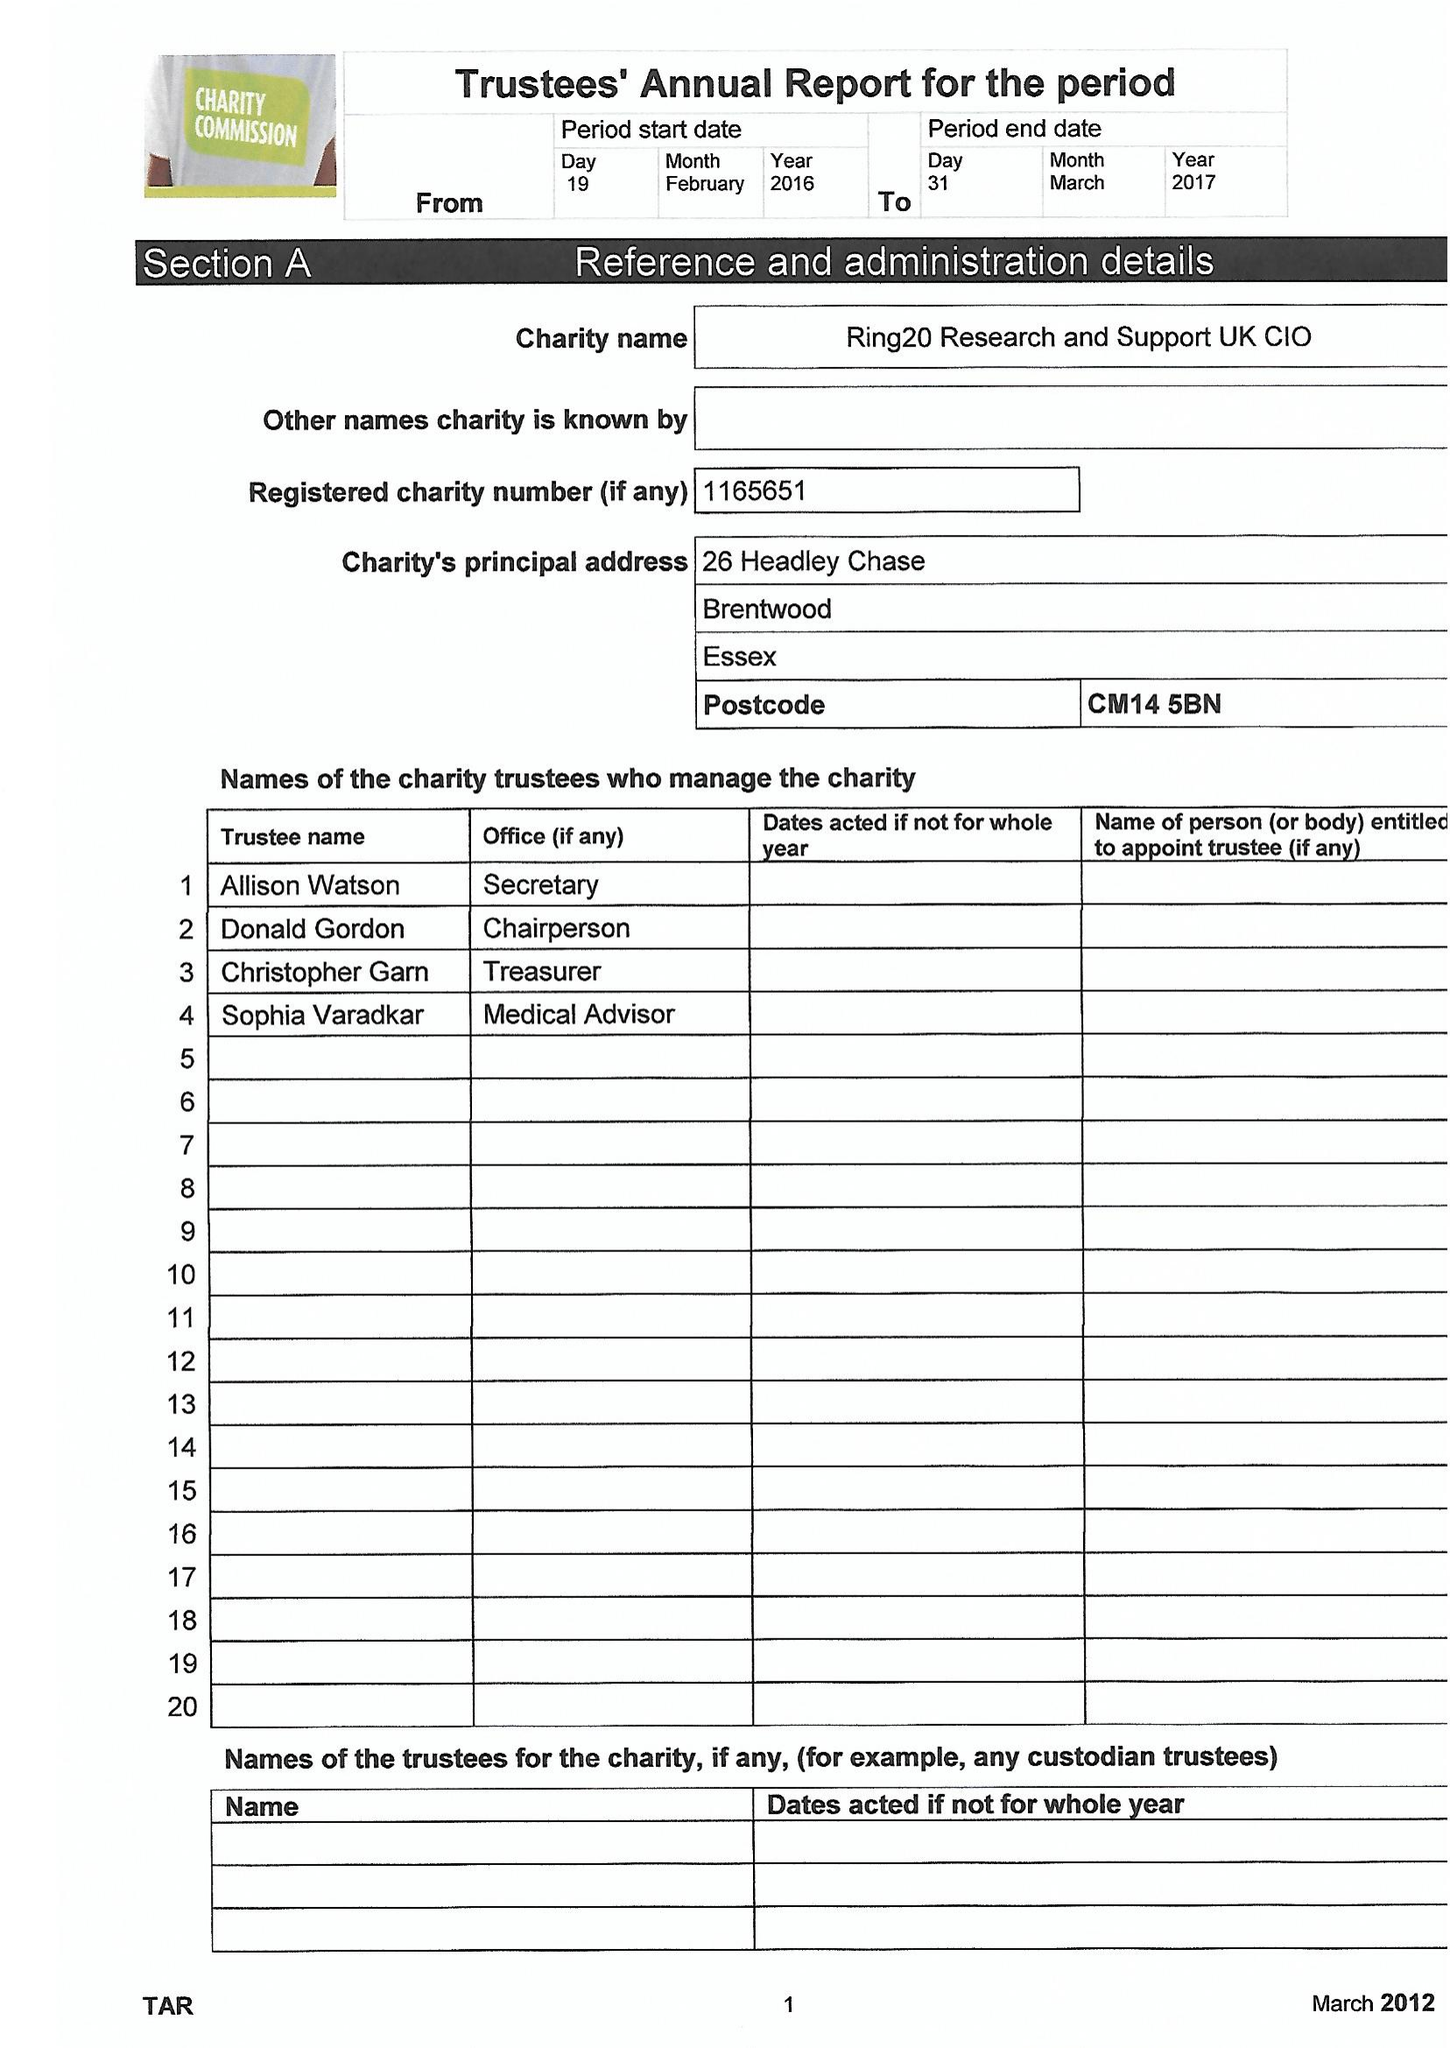What is the value for the charity_number?
Answer the question using a single word or phrase. 1165651 